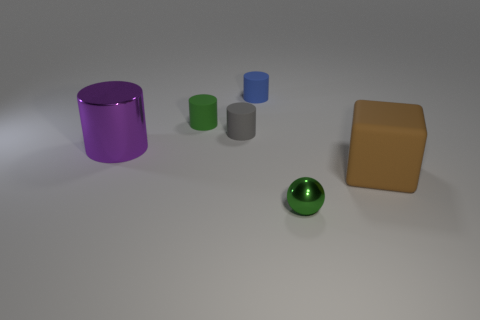What number of other objects are there of the same color as the metallic cylinder?
Your response must be concise. 0. There is a tiny green thing that is left of the object in front of the brown rubber block; what number of things are behind it?
Offer a terse response. 1. Is the size of the cylinder to the left of the green cylinder the same as the brown rubber block?
Ensure brevity in your answer.  Yes. Is the number of small blue cylinders right of the green metallic sphere less than the number of big purple objects that are right of the gray cylinder?
Provide a succinct answer. No. Is the number of matte objects that are to the right of the blue rubber thing less than the number of brown metallic cylinders?
Ensure brevity in your answer.  No. There is another tiny thing that is the same color as the small metallic object; what material is it?
Give a very brief answer. Rubber. Do the small gray thing and the ball have the same material?
Provide a short and direct response. No. How many small red balls have the same material as the purple cylinder?
Ensure brevity in your answer.  0. What color is the small object that is made of the same material as the big cylinder?
Your answer should be compact. Green. The small blue matte object has what shape?
Make the answer very short. Cylinder. 